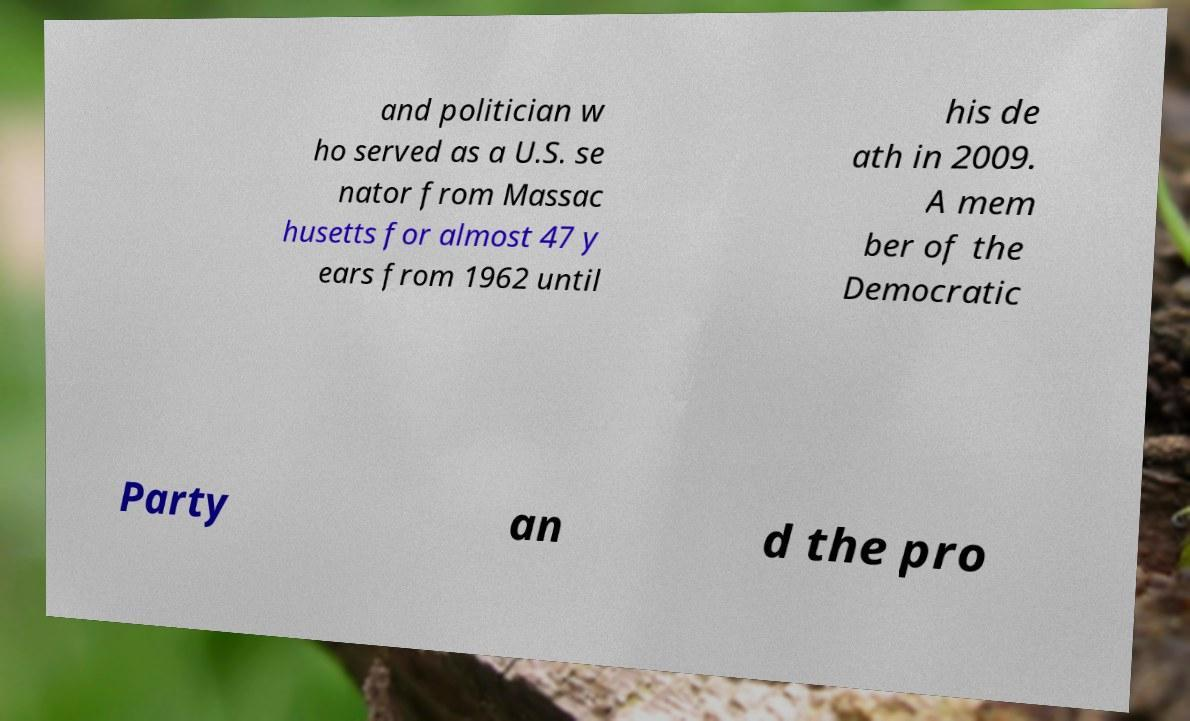For documentation purposes, I need the text within this image transcribed. Could you provide that? and politician w ho served as a U.S. se nator from Massac husetts for almost 47 y ears from 1962 until his de ath in 2009. A mem ber of the Democratic Party an d the pro 